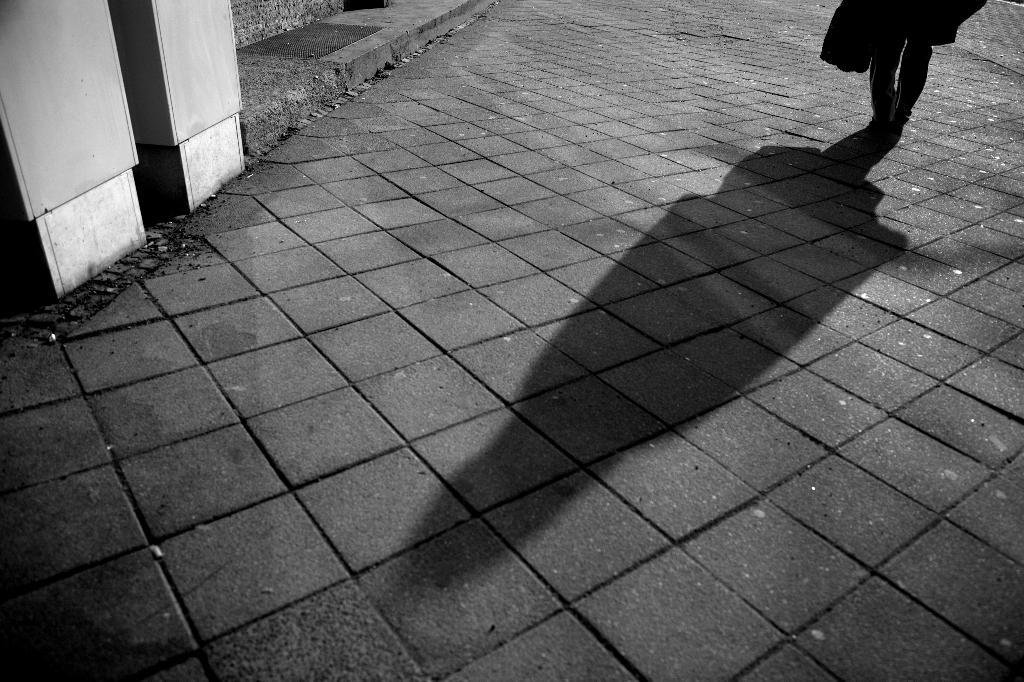What is the color scheme of the image? The image is black and white. Can you describe the main subject in the image? There is a person in the image. What is the person doing in the image? The person is standing on the ground. What type of payment is being made by the minister in the image? There is no minister or payment present in the image; it only features a person standing on the ground. 